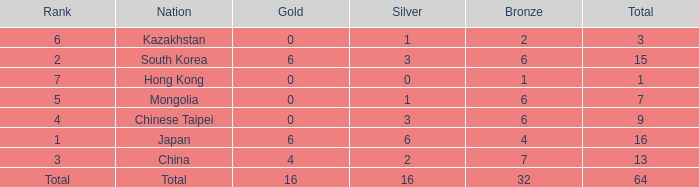Which Silver is the lowest one that has a Gold larger than 0, and a Rank of total, and a Bronze smaller than 32? None. 